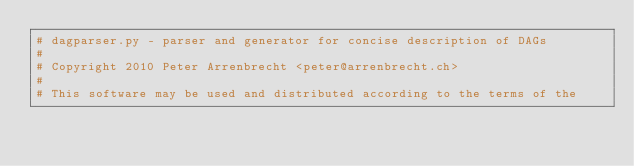Convert code to text. <code><loc_0><loc_0><loc_500><loc_500><_Python_># dagparser.py - parser and generator for concise description of DAGs
#
# Copyright 2010 Peter Arrenbrecht <peter@arrenbrecht.ch>
#
# This software may be used and distributed according to the terms of the</code> 